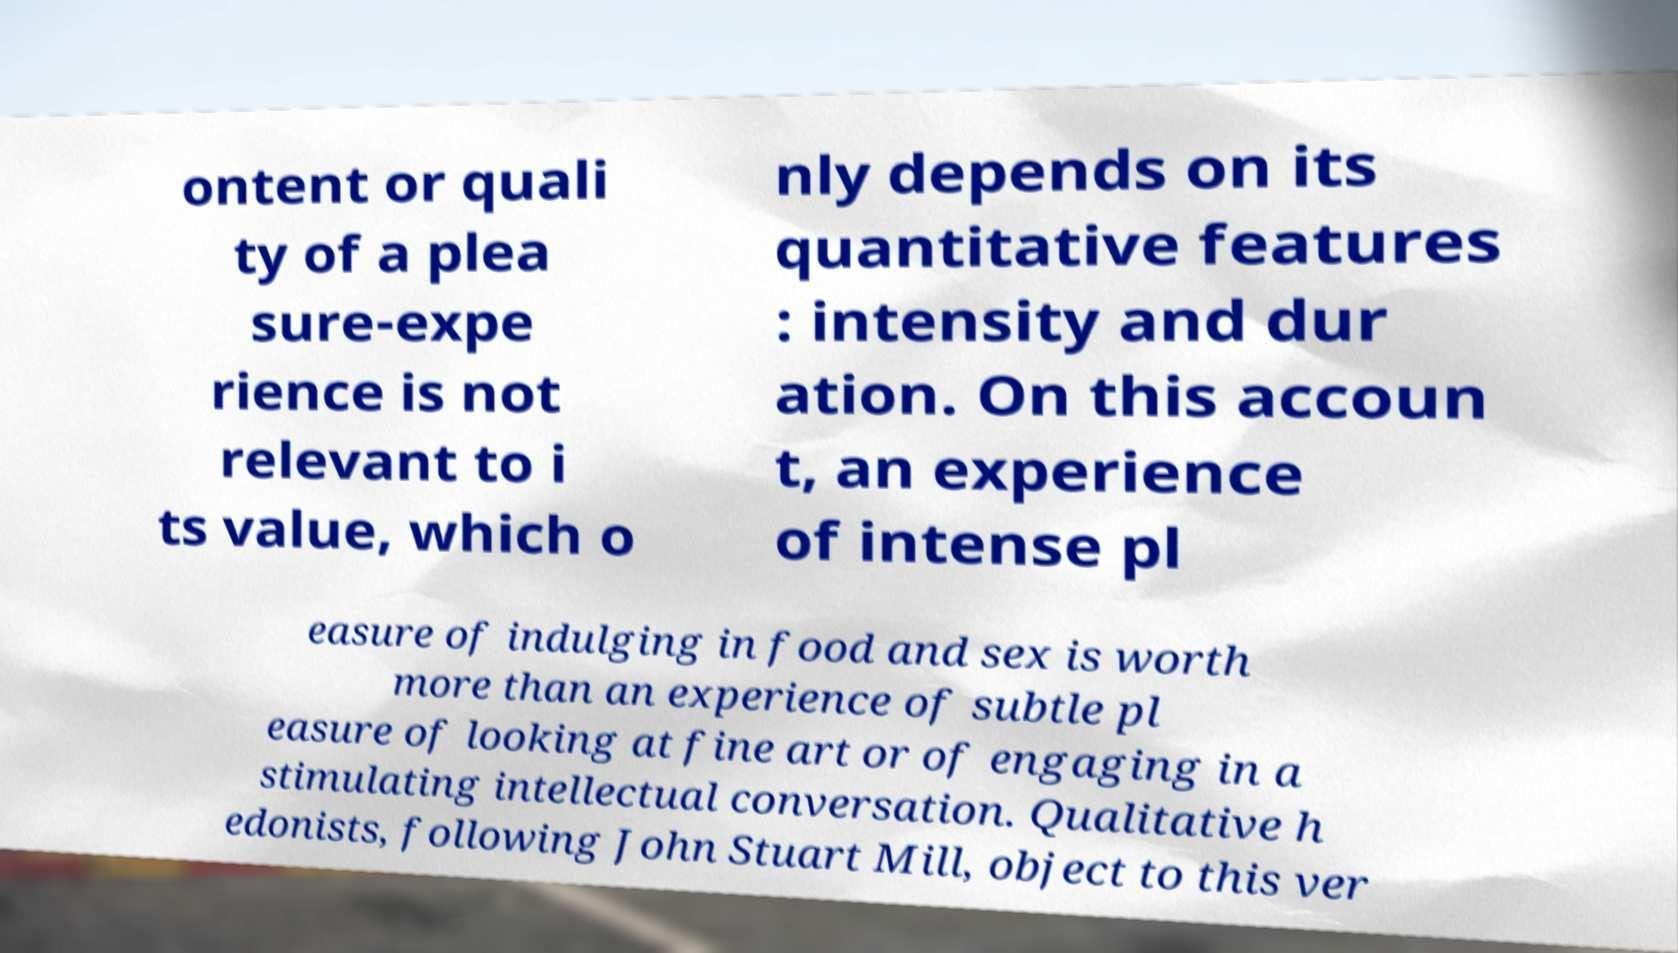Please read and relay the text visible in this image. What does it say? ontent or quali ty of a plea sure-expe rience is not relevant to i ts value, which o nly depends on its quantitative features : intensity and dur ation. On this accoun t, an experience of intense pl easure of indulging in food and sex is worth more than an experience of subtle pl easure of looking at fine art or of engaging in a stimulating intellectual conversation. Qualitative h edonists, following John Stuart Mill, object to this ver 